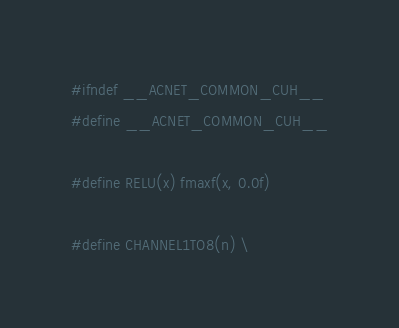<code> <loc_0><loc_0><loc_500><loc_500><_Cuda_>#ifndef __ACNET_COMMON_CUH__
#define __ACNET_COMMON_CUH__

#define RELU(x) fmaxf(x, 0.0f)

#define CHANNEL1TO8(n) \</code> 